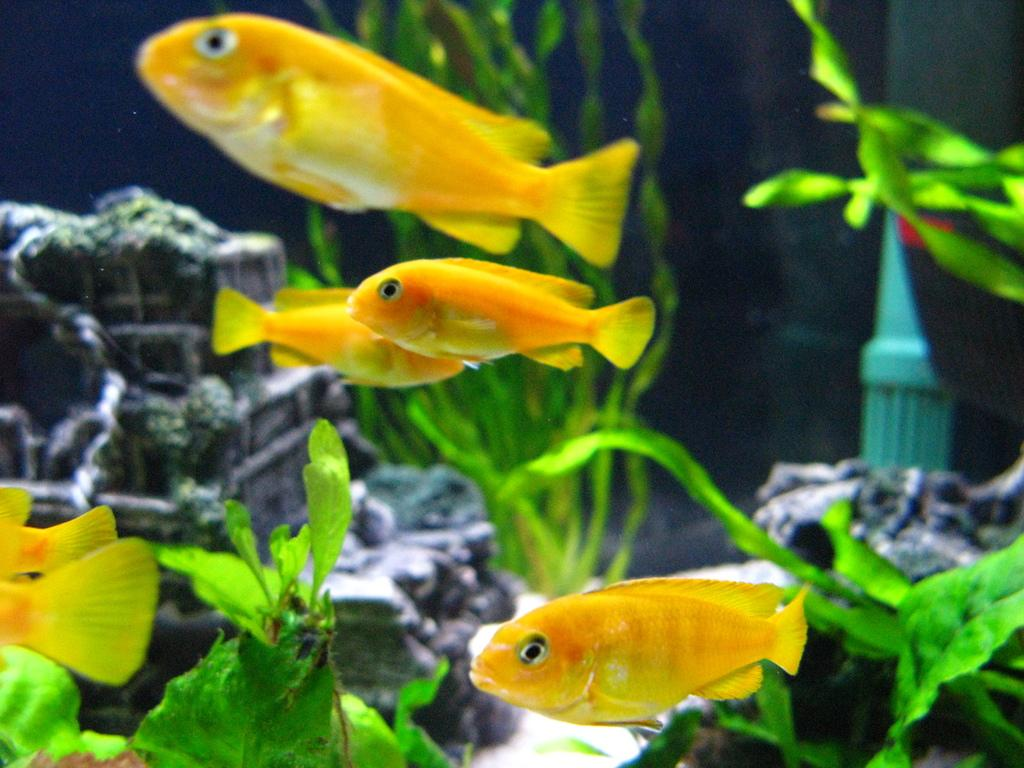What type of animals are in the image? There are fishes in the image. Where are the fishes located? The fishes are in an aquarium. What can be seen in the background of the image? There are plants in the background of the image. What type of farm can be seen in the image? There is no farm present in the image; it features an aquarium with fishes and plants in the background. How many fishes have died in the image? There is no indication of any fish deaths in the image; the fishes appear to be alive and swimming in the aquarium. 